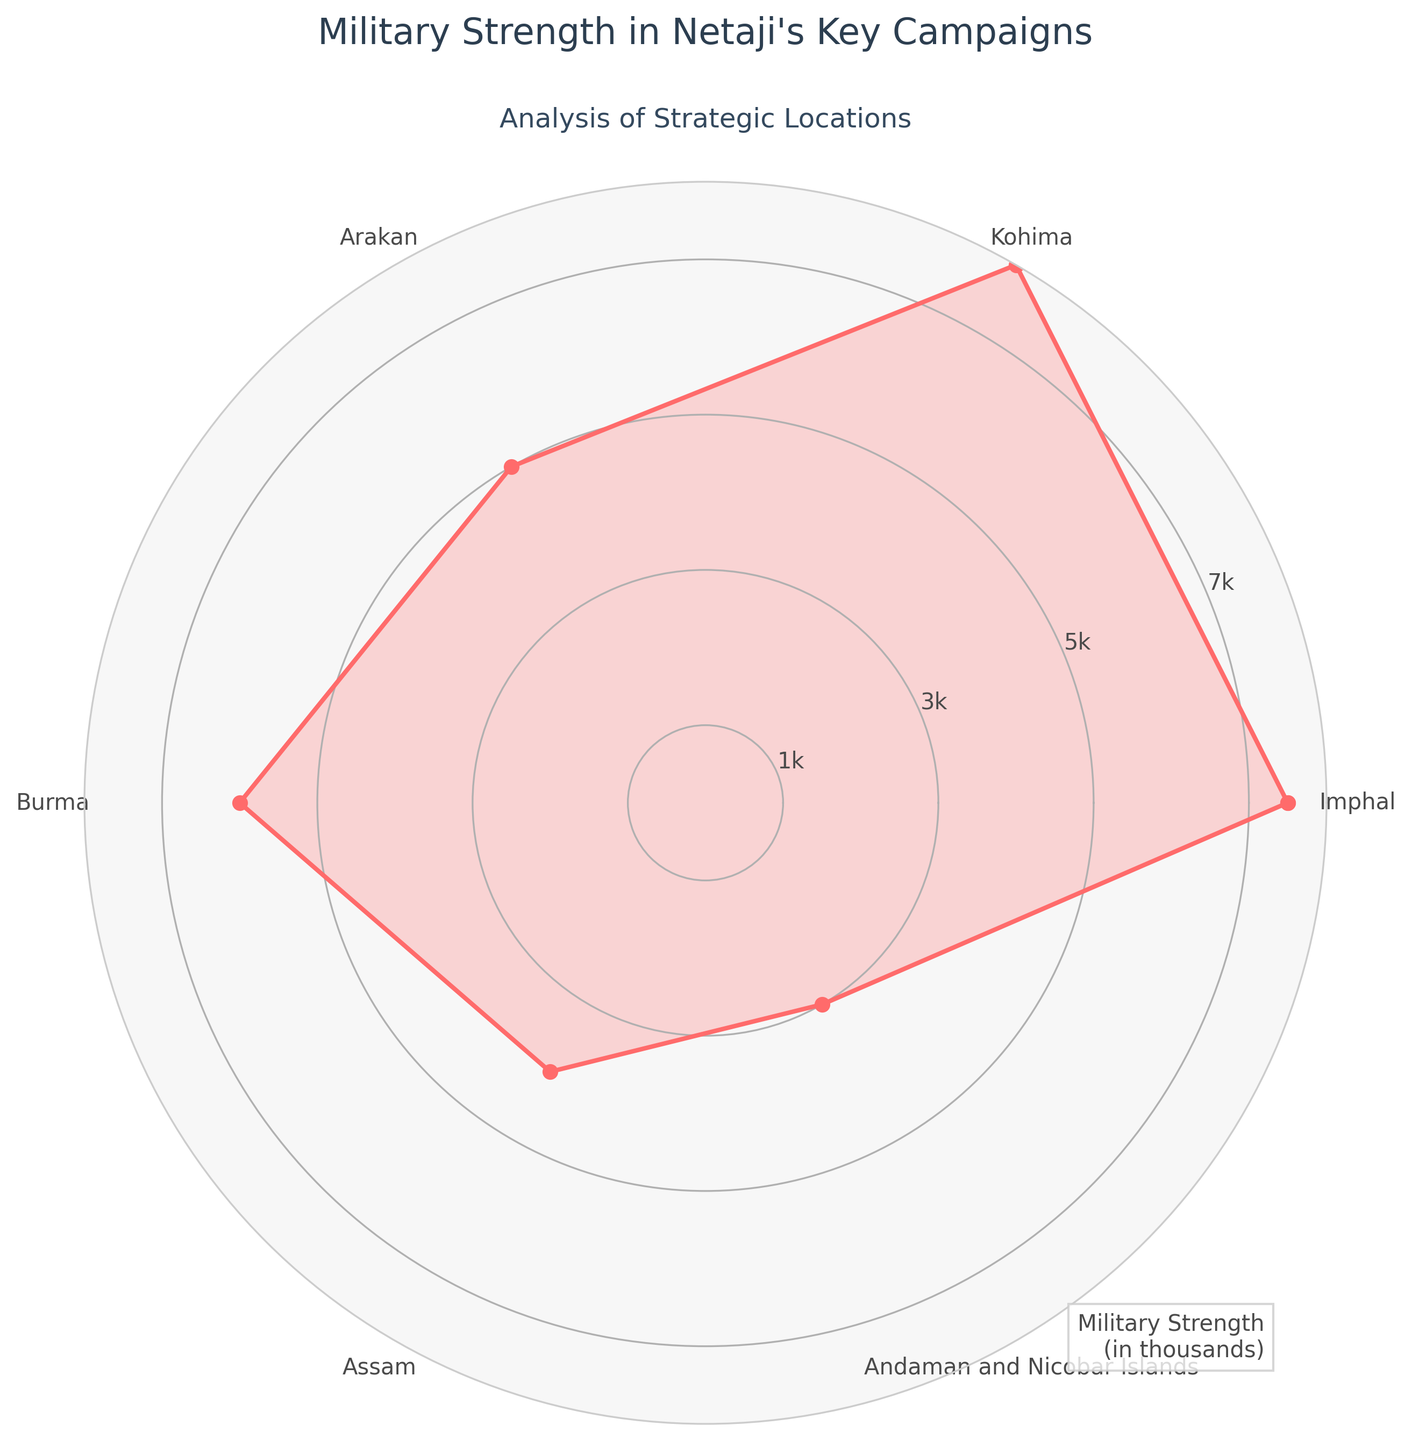How many strategic locations are shown in the radar chart? The radar chart has a plot point for each strategic location, and there are 6 points on the chart.
Answer: 6 Which strategic location had the highest military strength? The radar chart shows the most extended point corresponding to the highest military strength. The point labeled "Kohima" reaches the furthest, indicating 8000 military strength.
Answer: Kohima Which location had a strategic occupation? The radar chart has labels for each strategic location. The title "Strategic Occupation" matches the Andaman and Nicobar Islands location.
Answer: Andaman and Nicobar Islands How does the military strength in Imphal compare to that in Arakan? The chart shows military strength by the distance of the points from the center. Imphal has a point at 7.5 while Arakan is at 5, indicating that Imphal had a higher military strength.
Answer: Imphal is higher Which location had the lowest military strength, and what was the value? The point closest to the center represents the lowest. The Andaman and Nicobar Islands point is the closest and corresponds to a military strength value of 3000.
Answer: Andaman and Nicobar Islands, 3000 What is the average military strength across all strategic locations shown in the chart? Add the military strength values for all locations (7500 + 8000 + 5000 + 6000 + 4000 + 3000) and divide by the number of locations (6). The sum is 33500, and the average is 33500 / 6 ≈ 5583.
Answer: 5583 Which locations had military strengths above 6000, and what were their outcomes? From the radar chart, Kohima (8000) and Imphal (7500) had military strengths above 6000. Both ended in "Defeat."
Answer: Kohima and Imphal, Defeat How does the military strength at Burma compare to that of Assam? From the radar chart, we can see where the points for Burma and Assam are located. Burma had a strength of 6000 while Assam had 4000, so Burma's military strength was higher.
Answer: Burma is higher What is the total military strength depicted in the radar chart? To find the total, sum all the displayed military strengths (7500 + 8000 + 5000 + 6000 + 4000 + 3000). The total is 33500.
Answer: 33500 Which strategic location has a terrain difficulty of 7, and what is its military strength? The radar chart doesn't explicitly show terrain difficulty, but the column data indicates Arakan and the Andaman and Nicobar Islands have a terrain difficulty of 7. Their military strengths are 5000 and 3000, respectively.
Answer: Arakan: 5000, Andaman and Nicobar Islands: 3000 